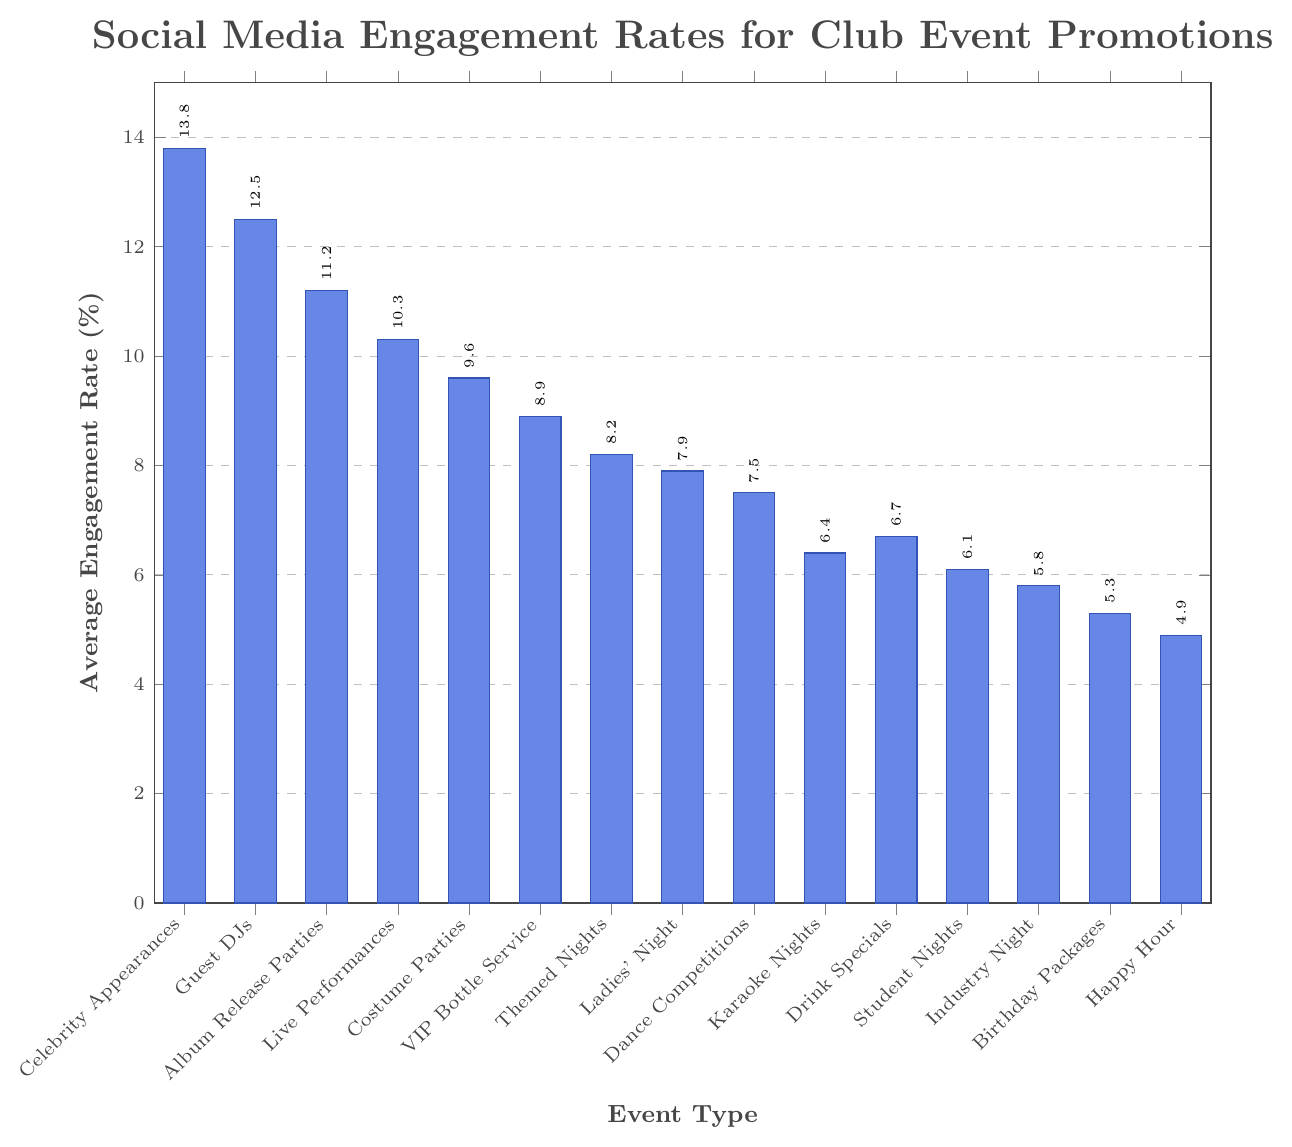What type of club event promotion has the highest social media engagement rate? The highest bar in the chart represents the event type with the highest engagement rate. This bar corresponds to "Celebrity Appearances," which has an engagement rate of 13.8%.
Answer: Celebrity Appearances Which event type has a lower engagement rate: Live Performances or Costume Parties? Live Performances have an engagement rate of 10.3%, while Costume Parties have a rate of 9.6%. Since 9.6% is lower than 10.3%, Costume Parties have a lower engagement rate.
Answer: Costume Parties What's the average engagement rate for events: Ladies' Night, Dance Competitions, and Karaoke Nights? First, find the engagement rates for each: Ladies' Night (7.9%), Dance Competitions (7.5%), and Karaoke Nights (6.4%). Sum these rates: 7.9 + 7.5 + 6.4 = 21.8. Then, divide by the number of events: 21.8 / 3 = 7.27.
Answer: 7.27% How much higher is the engagement rate for Guest DJs compared to Themed Nights? Guest DJs have a rate of 12.5% and Themed Nights have 8.2%. The difference is calculated as 12.5 - 8.2 = 4.3.
Answer: 4.3% Are there more events with an engagement rate above 10% or below 7%? Engagement rates above 10%: Celebrity Appearances (13.8%), Guest DJs (12.5%), Album Release Parties (11.2%), and Live Performances (10.3%). Total = 4 events. Engagement rates below 7%: Karaoke Nights (6.4%), Drink Specials (6.7%), Student Nights (6.1%), Industry Night (5.8%), Birthday Packages (5.3%), and Happy Hour (4.9%). Total = 6 events. Since there are more events below 7%, 6 > 4.
Answer: Below 7% What's the engagement rate difference between the average of the top three and the bottom three event types? Top three: Celebrity Appearances (13.8%), Guest DJs (12.5%), Album Release Parties (11.2%). Average of top three: (13.8 + 12.5 + 11.2) / 3 = 12.5%. Bottom three: Happy Hour (4.9%), Birthday Packages (5.3%), Industry Night (5.8%). Average of bottom three: (4.9 + 5.3 + 5.8) / 3 = 5.33%. Difference: 12.5 - 5.33 = 7.17.
Answer: 7.17% Which event type has the closest engagement rate to 7%? The engagement rates closest to 7% are Drink Specials (6.7%) and Dance Competitions (7.5%). Since 6.7% is closer to 7%, Drink Specials are closest.
Answer: Drink Specials 